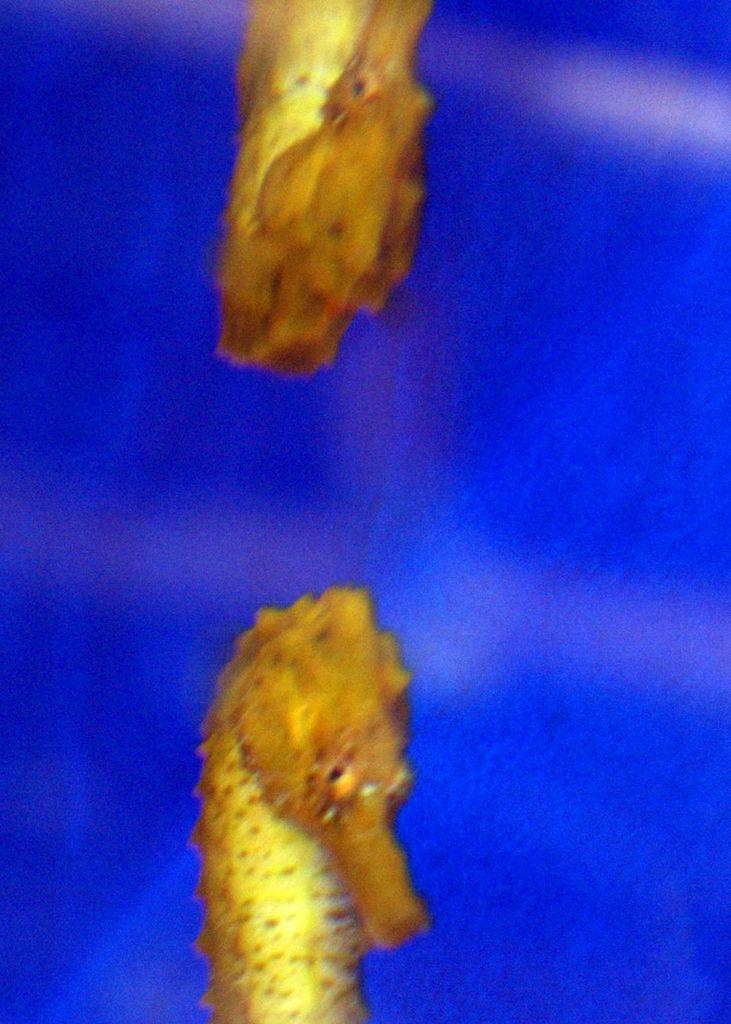What type of animals are in the image? There are two seahorse fishes in the image. What color is the background of the image? The background of the image is blue in color. What type of room is depicted in the image? There is no room depicted in the image; it features two seahorse fishes against a blue background. What can be used to cut paper in the image? There are no scissors or any cutting tools present in the image. 